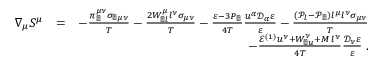Convert formula to latex. <formula><loc_0><loc_0><loc_500><loc_500>\begin{array} { r l r } { \nabla _ { \mu } S ^ { \mu } } & { = } & { - \frac { \pi _ { \perp } ^ { \mu \nu } \sigma _ { \perp \mu \nu } } { T } - \frac { 2 W _ { \perp l } ^ { \mu } l ^ { \nu } \sigma _ { \mu \nu } } { T } - \frac { \varepsilon - 3 P _ { \perp } } { 4 T } \frac { u ^ { \alpha } \mathcal { D } _ { \alpha } \varepsilon } { \varepsilon } - \frac { ( \mathcal { P } _ { l } - \mathcal { P } _ { \perp } ) l ^ { \mu } l ^ { \nu } \sigma _ { \mu \nu } } { T } } \\ & { - \frac { \mathcal { E } ^ { ( 1 ) } u ^ { \nu } + W _ { \perp u } ^ { \nu } + M \, l ^ { \nu } } { 4 T } \frac { \mathcal { D } _ { \nu } \varepsilon } { \varepsilon } \, . } \end{array}</formula> 